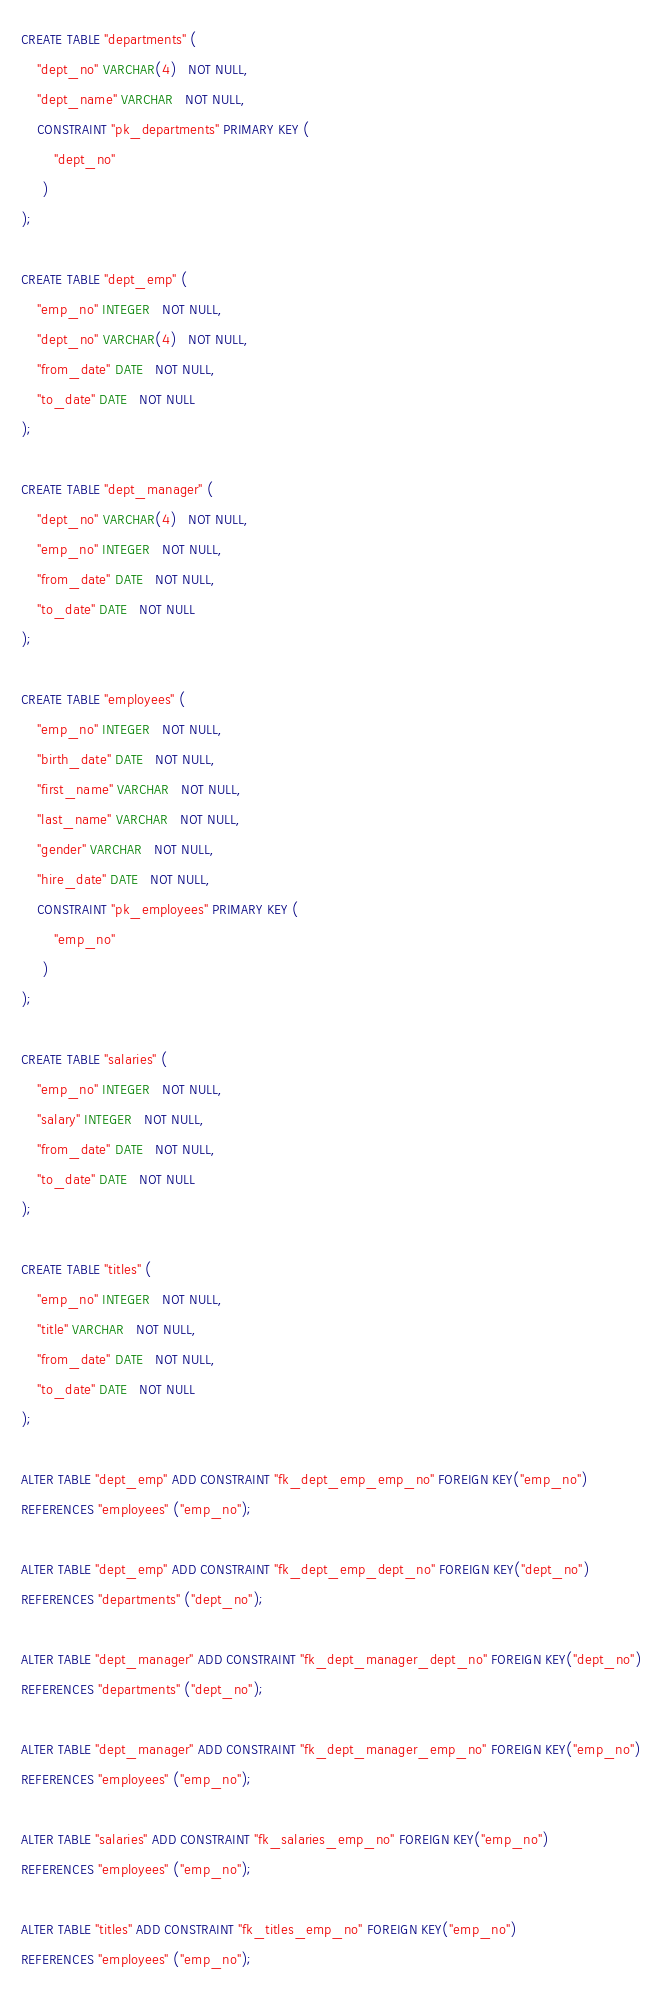Convert code to text. <code><loc_0><loc_0><loc_500><loc_500><_SQL_>CREATE TABLE "departments" (
    "dept_no" VARCHAR(4)   NOT NULL,
    "dept_name" VARCHAR   NOT NULL,
    CONSTRAINT "pk_departments" PRIMARY KEY (
        "dept_no"
     )
);

CREATE TABLE "dept_emp" (
    "emp_no" INTEGER   NOT NULL,
    "dept_no" VARCHAR(4)   NOT NULL,
    "from_date" DATE   NOT NULL,
    "to_date" DATE   NOT NULL
);

CREATE TABLE "dept_manager" (
    "dept_no" VARCHAR(4)   NOT NULL,
    "emp_no" INTEGER   NOT NULL,
    "from_date" DATE   NOT NULL,
    "to_date" DATE   NOT NULL
);

CREATE TABLE "employees" (
    "emp_no" INTEGER   NOT NULL,
    "birth_date" DATE   NOT NULL,
    "first_name" VARCHAR   NOT NULL,
    "last_name" VARCHAR   NOT NULL,
    "gender" VARCHAR   NOT NULL,
    "hire_date" DATE   NOT NULL,
    CONSTRAINT "pk_employees" PRIMARY KEY (
        "emp_no"
     )
);

CREATE TABLE "salaries" (
    "emp_no" INTEGER   NOT NULL,
    "salary" INTEGER   NOT NULL,
    "from_date" DATE   NOT NULL,
    "to_date" DATE   NOT NULL
);

CREATE TABLE "titles" (
    "emp_no" INTEGER   NOT NULL,
    "title" VARCHAR   NOT NULL,
    "from_date" DATE   NOT NULL,
    "to_date" DATE   NOT NULL
);

ALTER TABLE "dept_emp" ADD CONSTRAINT "fk_dept_emp_emp_no" FOREIGN KEY("emp_no")
REFERENCES "employees" ("emp_no");

ALTER TABLE "dept_emp" ADD CONSTRAINT "fk_dept_emp_dept_no" FOREIGN KEY("dept_no")
REFERENCES "departments" ("dept_no");

ALTER TABLE "dept_manager" ADD CONSTRAINT "fk_dept_manager_dept_no" FOREIGN KEY("dept_no")
REFERENCES "departments" ("dept_no");

ALTER TABLE "dept_manager" ADD CONSTRAINT "fk_dept_manager_emp_no" FOREIGN KEY("emp_no")
REFERENCES "employees" ("emp_no");

ALTER TABLE "salaries" ADD CONSTRAINT "fk_salaries_emp_no" FOREIGN KEY("emp_no")
REFERENCES "employees" ("emp_no");

ALTER TABLE "titles" ADD CONSTRAINT "fk_titles_emp_no" FOREIGN KEY("emp_no")
REFERENCES "employees" ("emp_no");
</code> 